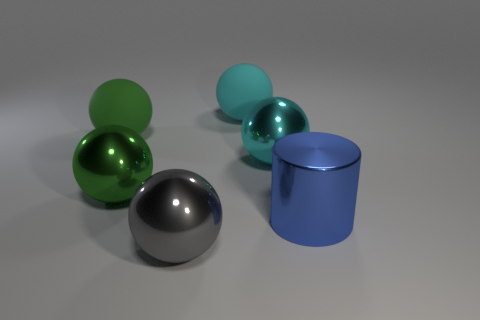Subtract 1 balls. How many balls are left? 4 Subtract all cyan spheres. How many spheres are left? 3 Subtract all gray metallic balls. How many balls are left? 4 Subtract all red balls. Subtract all cyan cylinders. How many balls are left? 5 Add 3 tiny cyan metal blocks. How many objects exist? 9 Subtract all cylinders. How many objects are left? 5 Subtract 0 gray cylinders. How many objects are left? 6 Subtract all big green rubber balls. Subtract all gray objects. How many objects are left? 4 Add 4 large cyan metallic things. How many large cyan metallic things are left? 5 Add 5 tiny brown matte balls. How many tiny brown matte balls exist? 5 